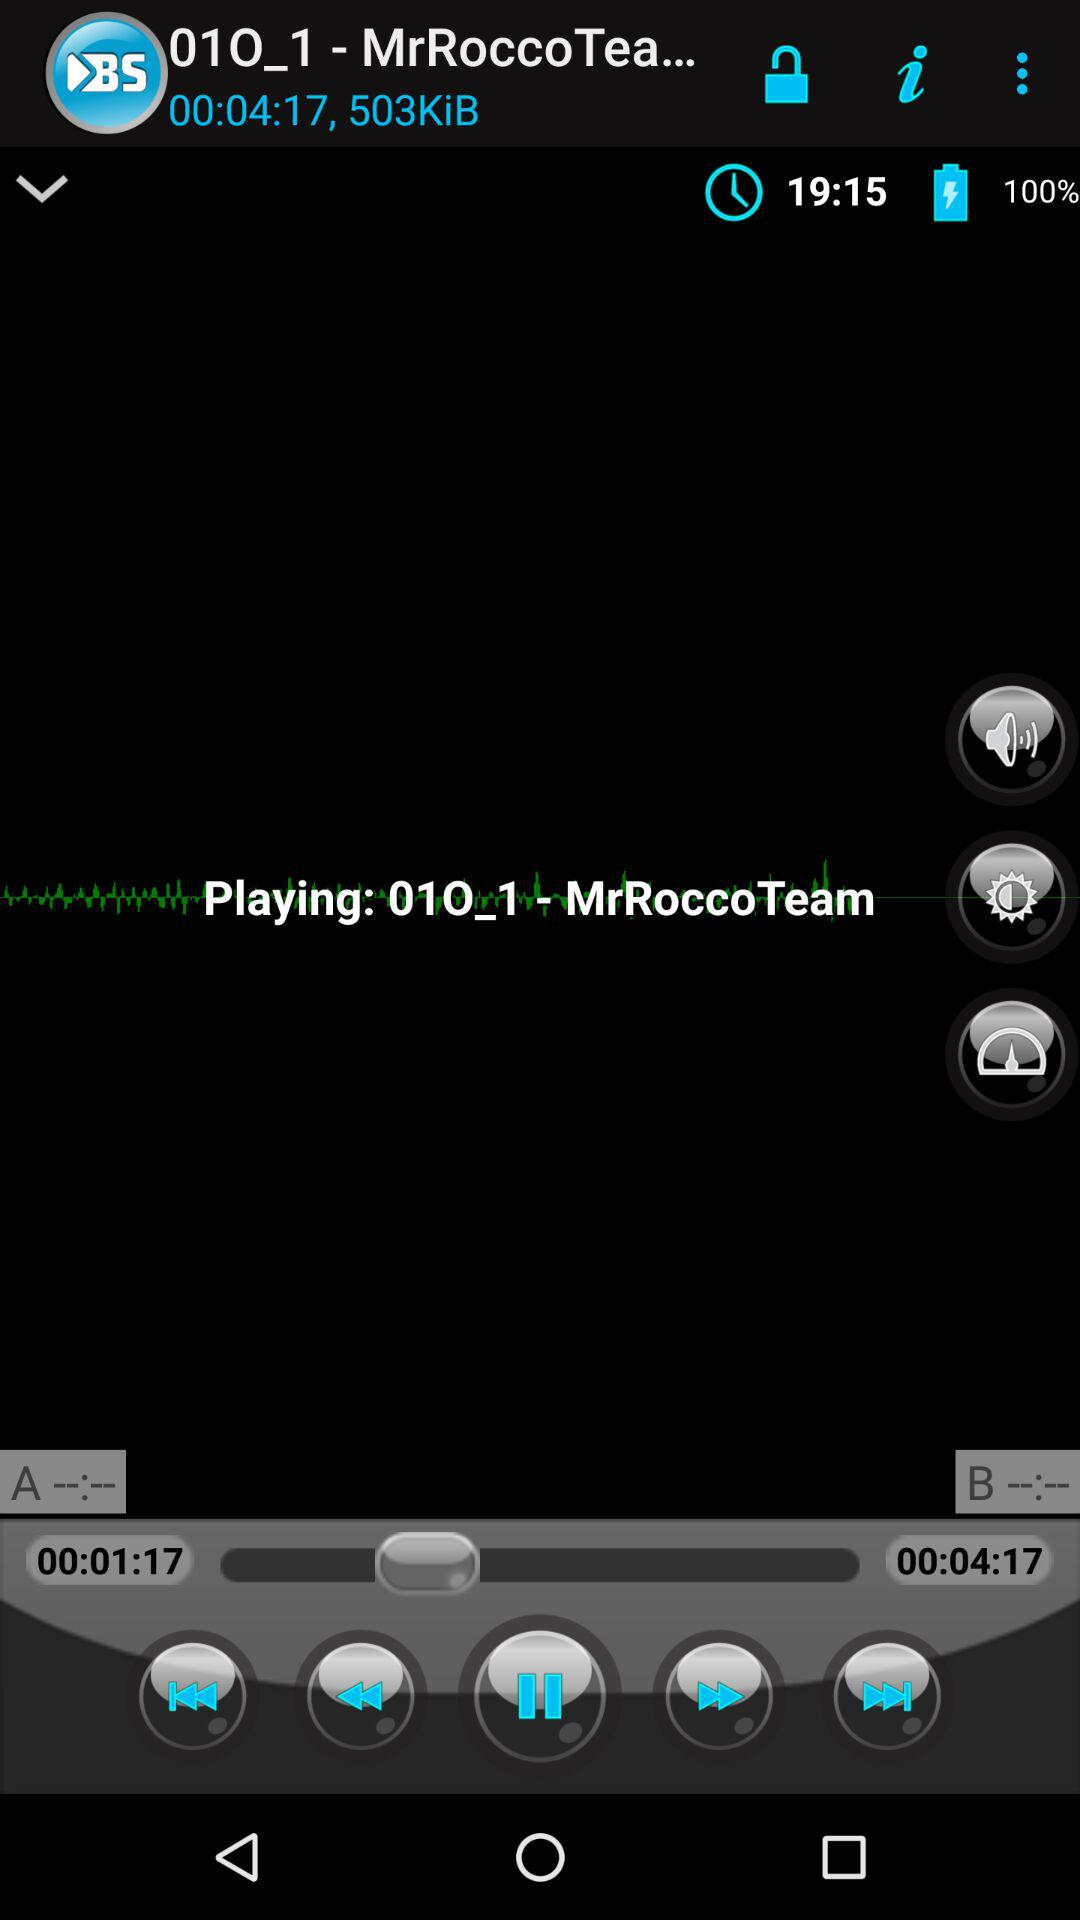What is the size of the audio file? The size of the audio file is 503 KiB. 